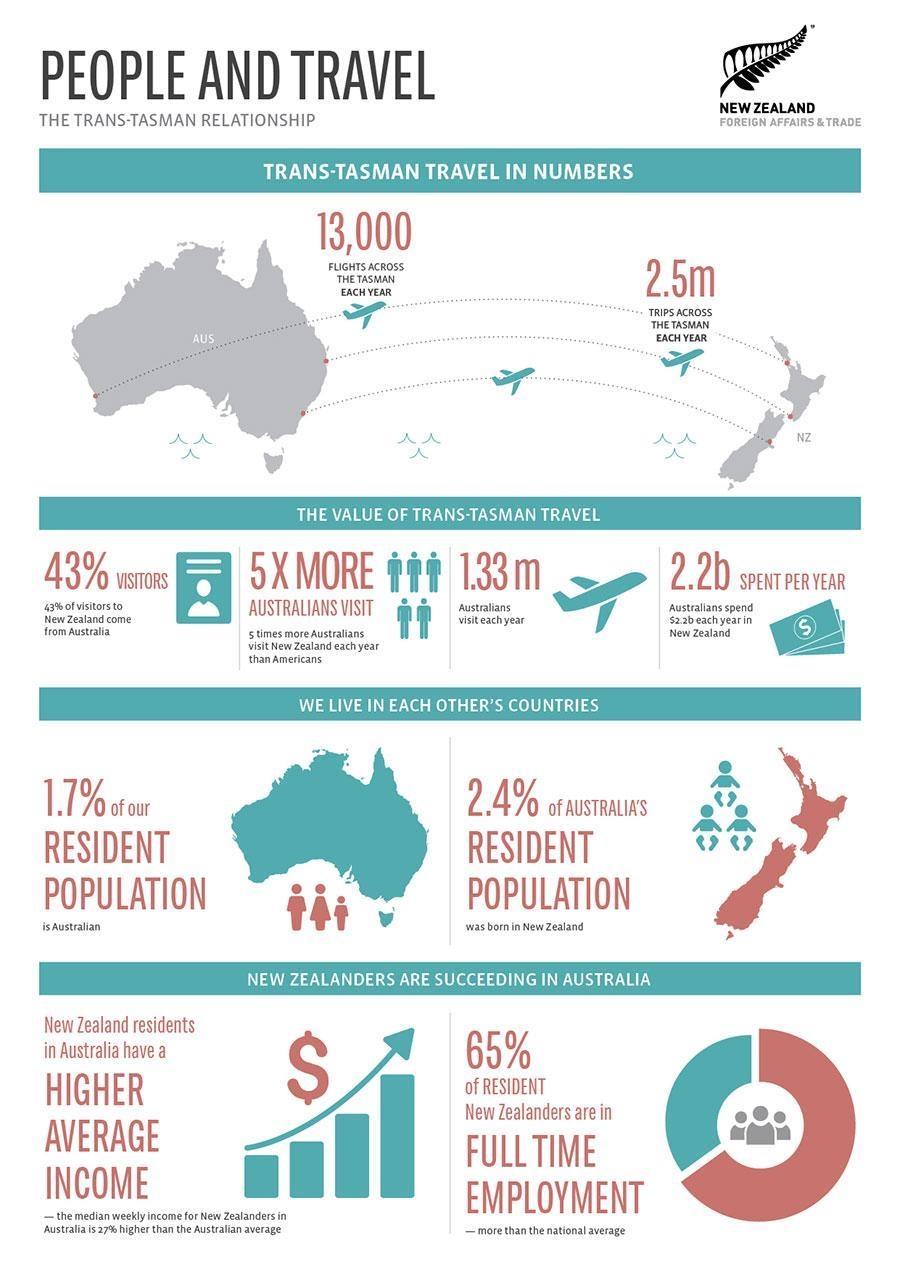What percentage of Australian's visit New Zealand every year?
Answer the question with a short phrase. 1.33 Million What percentage of resident New Zealanders are in full time employment? 65% What percentage of visitors to New Zealand comes from Australia? 43% What percentage of New Zealand's resident population lives in Australia? 1.7% What percentage of Australia's resident population are born in New Zealand? 2.4% What is the annual spent of Australian's in New Zealand? 2.2 Billion 